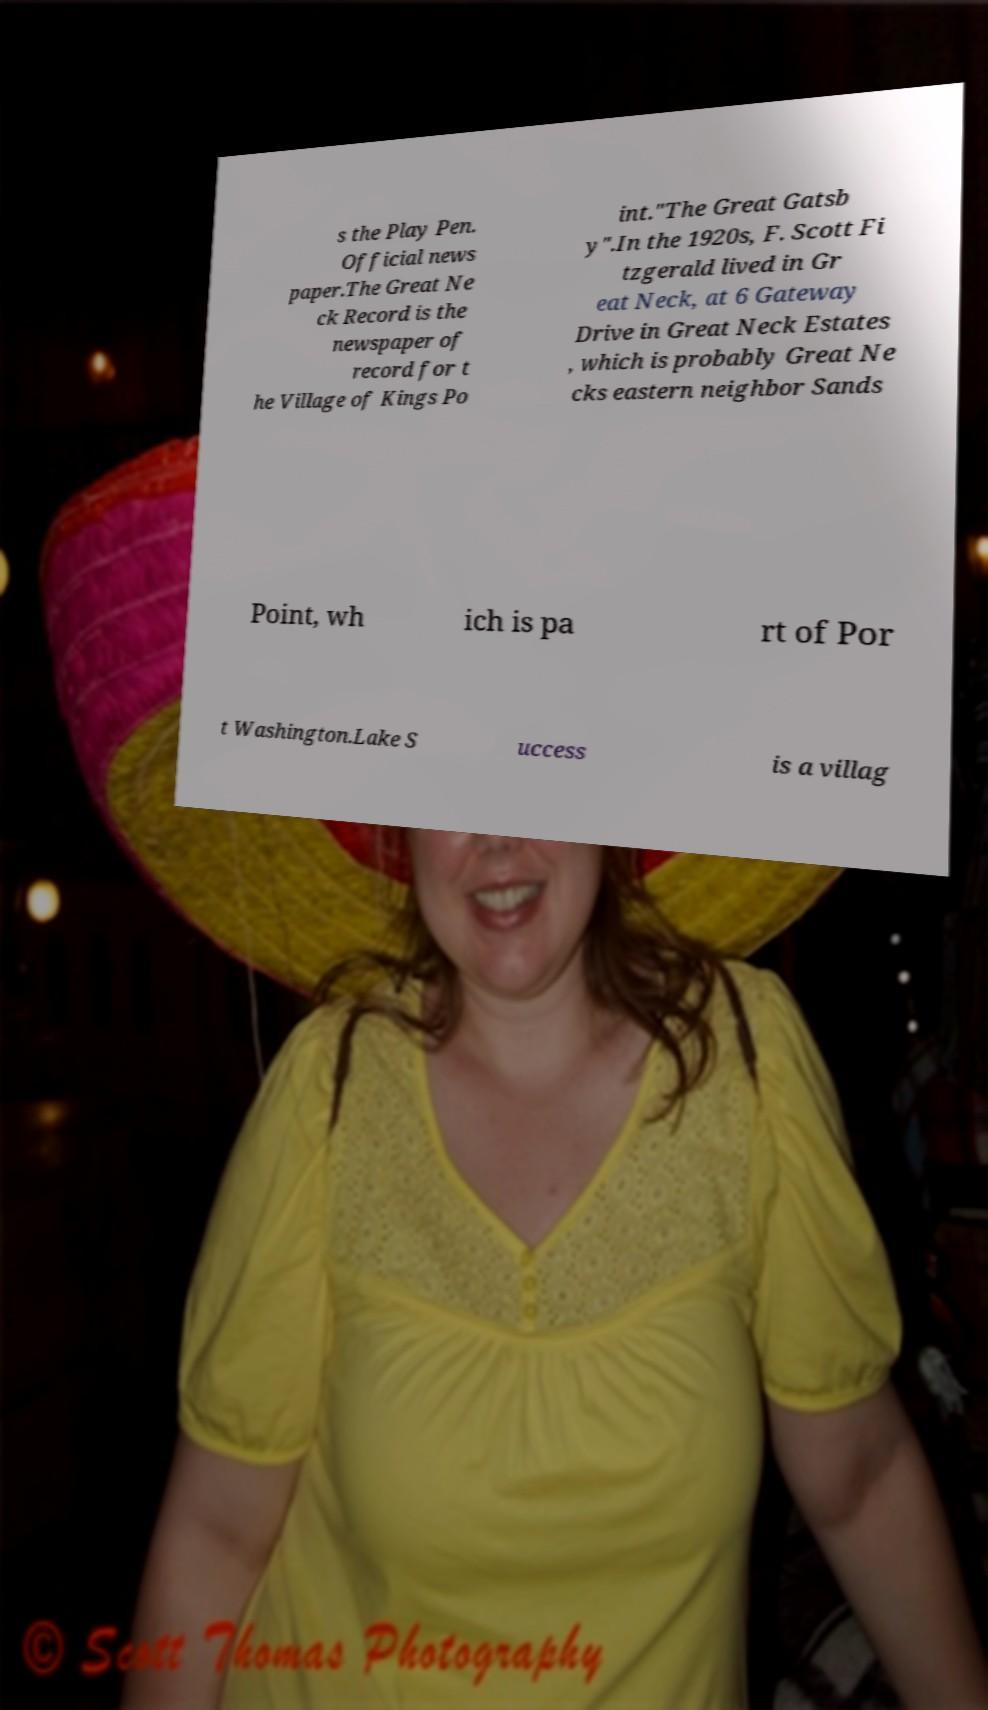Could you extract and type out the text from this image? s the Play Pen. Official news paper.The Great Ne ck Record is the newspaper of record for t he Village of Kings Po int."The Great Gatsb y".In the 1920s, F. Scott Fi tzgerald lived in Gr eat Neck, at 6 Gateway Drive in Great Neck Estates , which is probably Great Ne cks eastern neighbor Sands Point, wh ich is pa rt of Por t Washington.Lake S uccess is a villag 